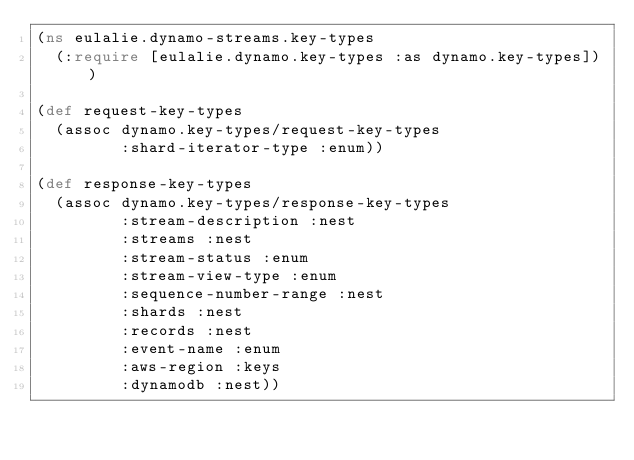<code> <loc_0><loc_0><loc_500><loc_500><_Clojure_>(ns eulalie.dynamo-streams.key-types
  (:require [eulalie.dynamo.key-types :as dynamo.key-types]))

(def request-key-types
  (assoc dynamo.key-types/request-key-types
         :shard-iterator-type :enum))

(def response-key-types
  (assoc dynamo.key-types/response-key-types
         :stream-description :nest
         :streams :nest
         :stream-status :enum
         :stream-view-type :enum
         :sequence-number-range :nest
         :shards :nest
         :records :nest
         :event-name :enum
         :aws-region :keys
         :dynamodb :nest))
</code> 